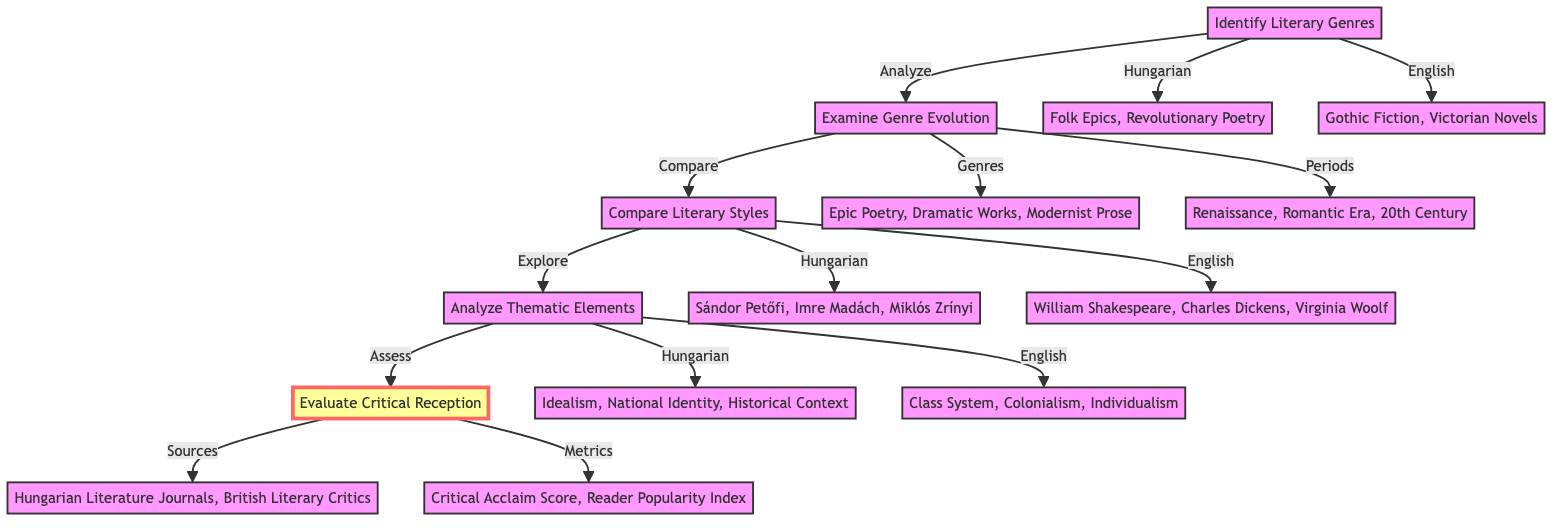What are the genres identified in Hungarian literature? According to the diagram, the genres identified in Hungarian literature are Folk Epics and Revolutionary Poetry, which are specifically listed under the "Identify Literary Genres" step.
Answer: Folk Epics, Revolutionary Poetry How many authors are compared in the "Compare Literary Styles"? The diagram shows two categories of authors under the "Compare Literary Styles" step: 3 Hungarian authors and 3 English authors, resulting in a total of 6 authors.
Answer: 6 authors What thematic elements are related to English literature? The "Analyze Thematic Elements" step lists the thematic elements related to English literature as Class System, Colonialism, and Individualism, which can be found in that section of the diagram.
Answer: Class System, Colonialism, Individualism What is the first step before "Evaluate Critical Reception"? The flow of the diagram shows that the first step before "Evaluate Critical Reception" is "Analyze Thematic Elements", indicating the direction of the process.
Answer: Analyze Thematic Elements Which genres are examined alongside "Dramatic Works"? Within the "Examine Genre Evolution" step, the genres are listed together; alongside "Dramatic Works", the other genres are Epic Poetry and Modernist Prose, both of which are mentioned in the same context.
Answer: Epic Poetry, Dramatic Works, Modernist Prose How many metrics are used to evaluate critical reception? In the "Evaluate Critical Reception" step, there are two metrics listed: Critical Acclaim Score and Reader Popularity Index, giving a total of 2 metrics used for evaluation purposes.
Answer: 2 metrics What is the last step in the flowchart? The flowchart demonstrates that the last step in the process is "Evaluate Critical Reception", which is positioned at the top of the diagram as the final action to take after completing all prior steps.
Answer: Evaluate Critical Reception What is the second step in the comparative analysis? Observing the diagram's flow, the second step in the comparative analysis is "Examine Genre Evolution", which follows directly after "Identify Literary Genres".
Answer: Examine Genre Evolution Which group of authors is associated with Hungarian literature? The "Compare Literary Styles" step identifies the Hungarian authors as Sándor Petőfi, Imre Madách, and Miklós Zrínyi, specifically mentioning them in this context of comparison.
Answer: Sándor Petőfi, Imre Madách, Miklós Zrínyi 